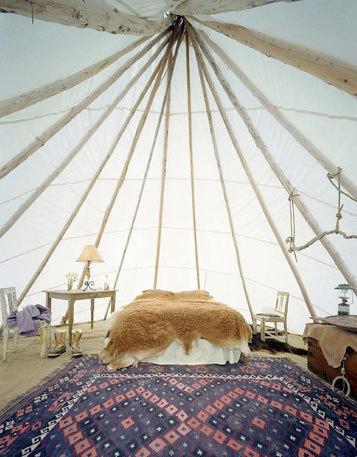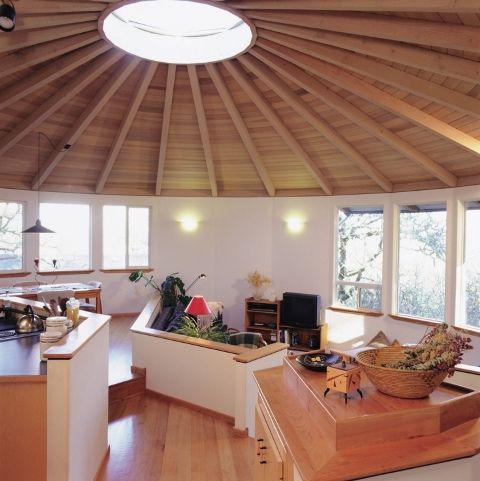The first image is the image on the left, the second image is the image on the right. Considering the images on both sides, is "The image on the right contains at least one set of bunk beds." valid? Answer yes or no. No. The first image is the image on the left, the second image is the image on the right. Assess this claim about the two images: "There is wooden floor in both images.". Correct or not? Answer yes or no. No. 